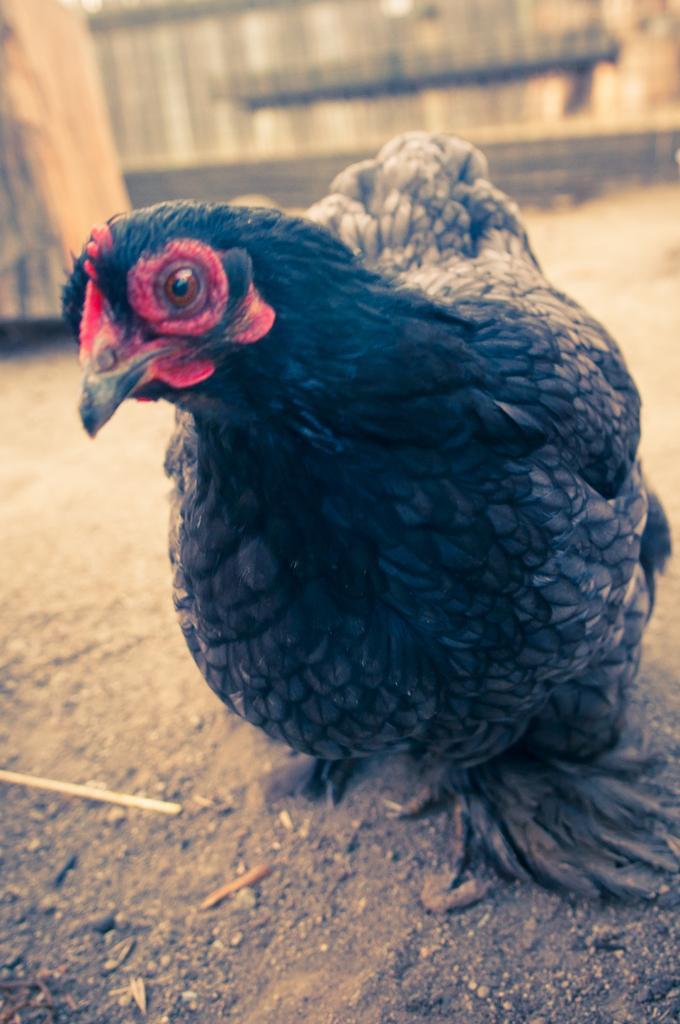In one or two sentences, can you explain what this image depicts? In this picture I can observe a bird which is in black color on the land. It is looking like a hen. The background is blurred. 